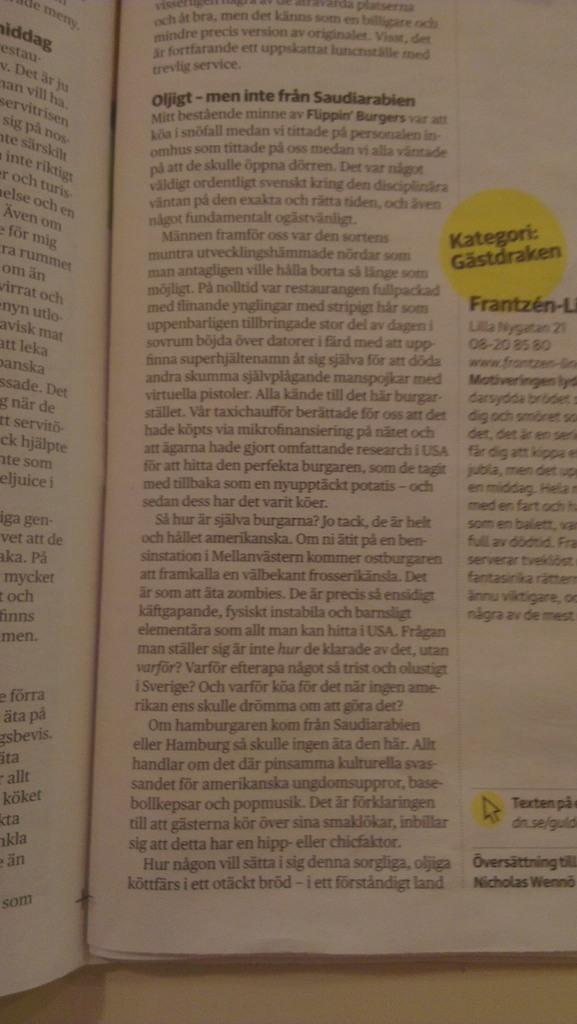<image>
Share a concise interpretation of the image provided. A magazine with a sticker that says Kategori Gastdraken. 